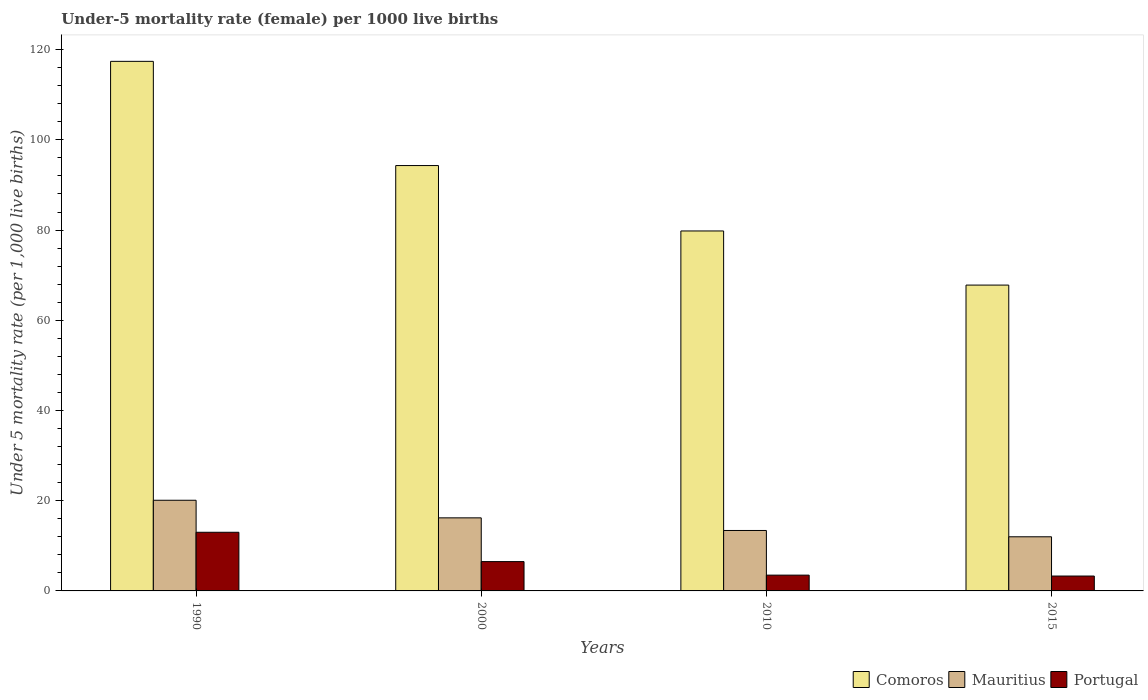How many different coloured bars are there?
Provide a short and direct response. 3. How many groups of bars are there?
Keep it short and to the point. 4. Are the number of bars per tick equal to the number of legend labels?
Ensure brevity in your answer.  Yes. Are the number of bars on each tick of the X-axis equal?
Your answer should be compact. Yes. How many bars are there on the 4th tick from the left?
Your answer should be compact. 3. How many bars are there on the 1st tick from the right?
Your answer should be very brief. 3. In how many cases, is the number of bars for a given year not equal to the number of legend labels?
Give a very brief answer. 0. What is the under-five mortality rate in Comoros in 2000?
Your answer should be very brief. 94.3. Across all years, what is the maximum under-five mortality rate in Comoros?
Keep it short and to the point. 117.4. In which year was the under-five mortality rate in Portugal maximum?
Your answer should be very brief. 1990. In which year was the under-five mortality rate in Comoros minimum?
Keep it short and to the point. 2015. What is the total under-five mortality rate in Portugal in the graph?
Your answer should be very brief. 26.3. What is the difference between the under-five mortality rate in Portugal in 2010 and that in 2015?
Your answer should be very brief. 0.2. What is the difference between the under-five mortality rate in Portugal in 2000 and the under-five mortality rate in Mauritius in 2010?
Your response must be concise. -6.9. What is the average under-five mortality rate in Mauritius per year?
Ensure brevity in your answer.  15.42. In the year 2010, what is the difference between the under-five mortality rate in Comoros and under-five mortality rate in Portugal?
Your answer should be very brief. 76.3. In how many years, is the under-five mortality rate in Portugal greater than 52?
Provide a succinct answer. 0. Is the under-five mortality rate in Portugal in 1990 less than that in 2000?
Ensure brevity in your answer.  No. What is the difference between the highest and the second highest under-five mortality rate in Portugal?
Give a very brief answer. 6.5. What is the difference between the highest and the lowest under-five mortality rate in Comoros?
Ensure brevity in your answer.  49.6. What does the 1st bar from the left in 1990 represents?
Give a very brief answer. Comoros. Is it the case that in every year, the sum of the under-five mortality rate in Comoros and under-five mortality rate in Portugal is greater than the under-five mortality rate in Mauritius?
Your response must be concise. Yes. How many years are there in the graph?
Give a very brief answer. 4. What is the difference between two consecutive major ticks on the Y-axis?
Give a very brief answer. 20. Are the values on the major ticks of Y-axis written in scientific E-notation?
Provide a succinct answer. No. Where does the legend appear in the graph?
Provide a short and direct response. Bottom right. What is the title of the graph?
Give a very brief answer. Under-5 mortality rate (female) per 1000 live births. Does "Lesotho" appear as one of the legend labels in the graph?
Ensure brevity in your answer.  No. What is the label or title of the Y-axis?
Keep it short and to the point. Under 5 mortality rate (per 1,0 live births). What is the Under 5 mortality rate (per 1,000 live births) in Comoros in 1990?
Ensure brevity in your answer.  117.4. What is the Under 5 mortality rate (per 1,000 live births) in Mauritius in 1990?
Your answer should be compact. 20.1. What is the Under 5 mortality rate (per 1,000 live births) in Portugal in 1990?
Your response must be concise. 13. What is the Under 5 mortality rate (per 1,000 live births) of Comoros in 2000?
Make the answer very short. 94.3. What is the Under 5 mortality rate (per 1,000 live births) in Mauritius in 2000?
Your answer should be compact. 16.2. What is the Under 5 mortality rate (per 1,000 live births) of Portugal in 2000?
Make the answer very short. 6.5. What is the Under 5 mortality rate (per 1,000 live births) in Comoros in 2010?
Offer a very short reply. 79.8. What is the Under 5 mortality rate (per 1,000 live births) of Mauritius in 2010?
Keep it short and to the point. 13.4. What is the Under 5 mortality rate (per 1,000 live births) of Portugal in 2010?
Ensure brevity in your answer.  3.5. What is the Under 5 mortality rate (per 1,000 live births) in Comoros in 2015?
Offer a terse response. 67.8. Across all years, what is the maximum Under 5 mortality rate (per 1,000 live births) of Comoros?
Your answer should be very brief. 117.4. Across all years, what is the maximum Under 5 mortality rate (per 1,000 live births) of Mauritius?
Provide a succinct answer. 20.1. Across all years, what is the minimum Under 5 mortality rate (per 1,000 live births) in Comoros?
Your answer should be very brief. 67.8. Across all years, what is the minimum Under 5 mortality rate (per 1,000 live births) of Portugal?
Your answer should be compact. 3.3. What is the total Under 5 mortality rate (per 1,000 live births) of Comoros in the graph?
Give a very brief answer. 359.3. What is the total Under 5 mortality rate (per 1,000 live births) in Mauritius in the graph?
Offer a terse response. 61.7. What is the total Under 5 mortality rate (per 1,000 live births) in Portugal in the graph?
Provide a succinct answer. 26.3. What is the difference between the Under 5 mortality rate (per 1,000 live births) of Comoros in 1990 and that in 2000?
Your answer should be compact. 23.1. What is the difference between the Under 5 mortality rate (per 1,000 live births) of Portugal in 1990 and that in 2000?
Give a very brief answer. 6.5. What is the difference between the Under 5 mortality rate (per 1,000 live births) in Comoros in 1990 and that in 2010?
Provide a short and direct response. 37.6. What is the difference between the Under 5 mortality rate (per 1,000 live births) of Mauritius in 1990 and that in 2010?
Your answer should be very brief. 6.7. What is the difference between the Under 5 mortality rate (per 1,000 live births) of Portugal in 1990 and that in 2010?
Your answer should be compact. 9.5. What is the difference between the Under 5 mortality rate (per 1,000 live births) in Comoros in 1990 and that in 2015?
Your response must be concise. 49.6. What is the difference between the Under 5 mortality rate (per 1,000 live births) of Mauritius in 1990 and that in 2015?
Ensure brevity in your answer.  8.1. What is the difference between the Under 5 mortality rate (per 1,000 live births) of Mauritius in 2000 and that in 2010?
Give a very brief answer. 2.8. What is the difference between the Under 5 mortality rate (per 1,000 live births) in Portugal in 2000 and that in 2010?
Keep it short and to the point. 3. What is the difference between the Under 5 mortality rate (per 1,000 live births) in Comoros in 2000 and that in 2015?
Offer a very short reply. 26.5. What is the difference between the Under 5 mortality rate (per 1,000 live births) in Mauritius in 2000 and that in 2015?
Provide a succinct answer. 4.2. What is the difference between the Under 5 mortality rate (per 1,000 live births) of Portugal in 2010 and that in 2015?
Your answer should be very brief. 0.2. What is the difference between the Under 5 mortality rate (per 1,000 live births) of Comoros in 1990 and the Under 5 mortality rate (per 1,000 live births) of Mauritius in 2000?
Offer a terse response. 101.2. What is the difference between the Under 5 mortality rate (per 1,000 live births) of Comoros in 1990 and the Under 5 mortality rate (per 1,000 live births) of Portugal in 2000?
Give a very brief answer. 110.9. What is the difference between the Under 5 mortality rate (per 1,000 live births) of Comoros in 1990 and the Under 5 mortality rate (per 1,000 live births) of Mauritius in 2010?
Your answer should be compact. 104. What is the difference between the Under 5 mortality rate (per 1,000 live births) of Comoros in 1990 and the Under 5 mortality rate (per 1,000 live births) of Portugal in 2010?
Your answer should be very brief. 113.9. What is the difference between the Under 5 mortality rate (per 1,000 live births) of Mauritius in 1990 and the Under 5 mortality rate (per 1,000 live births) of Portugal in 2010?
Make the answer very short. 16.6. What is the difference between the Under 5 mortality rate (per 1,000 live births) in Comoros in 1990 and the Under 5 mortality rate (per 1,000 live births) in Mauritius in 2015?
Provide a succinct answer. 105.4. What is the difference between the Under 5 mortality rate (per 1,000 live births) in Comoros in 1990 and the Under 5 mortality rate (per 1,000 live births) in Portugal in 2015?
Your answer should be compact. 114.1. What is the difference between the Under 5 mortality rate (per 1,000 live births) of Comoros in 2000 and the Under 5 mortality rate (per 1,000 live births) of Mauritius in 2010?
Keep it short and to the point. 80.9. What is the difference between the Under 5 mortality rate (per 1,000 live births) in Comoros in 2000 and the Under 5 mortality rate (per 1,000 live births) in Portugal in 2010?
Your response must be concise. 90.8. What is the difference between the Under 5 mortality rate (per 1,000 live births) in Comoros in 2000 and the Under 5 mortality rate (per 1,000 live births) in Mauritius in 2015?
Your answer should be compact. 82.3. What is the difference between the Under 5 mortality rate (per 1,000 live births) of Comoros in 2000 and the Under 5 mortality rate (per 1,000 live births) of Portugal in 2015?
Your answer should be very brief. 91. What is the difference between the Under 5 mortality rate (per 1,000 live births) in Mauritius in 2000 and the Under 5 mortality rate (per 1,000 live births) in Portugal in 2015?
Ensure brevity in your answer.  12.9. What is the difference between the Under 5 mortality rate (per 1,000 live births) of Comoros in 2010 and the Under 5 mortality rate (per 1,000 live births) of Mauritius in 2015?
Ensure brevity in your answer.  67.8. What is the difference between the Under 5 mortality rate (per 1,000 live births) in Comoros in 2010 and the Under 5 mortality rate (per 1,000 live births) in Portugal in 2015?
Provide a succinct answer. 76.5. What is the average Under 5 mortality rate (per 1,000 live births) in Comoros per year?
Give a very brief answer. 89.83. What is the average Under 5 mortality rate (per 1,000 live births) of Mauritius per year?
Your answer should be very brief. 15.43. What is the average Under 5 mortality rate (per 1,000 live births) in Portugal per year?
Your response must be concise. 6.58. In the year 1990, what is the difference between the Under 5 mortality rate (per 1,000 live births) in Comoros and Under 5 mortality rate (per 1,000 live births) in Mauritius?
Provide a short and direct response. 97.3. In the year 1990, what is the difference between the Under 5 mortality rate (per 1,000 live births) in Comoros and Under 5 mortality rate (per 1,000 live births) in Portugal?
Your answer should be compact. 104.4. In the year 2000, what is the difference between the Under 5 mortality rate (per 1,000 live births) in Comoros and Under 5 mortality rate (per 1,000 live births) in Mauritius?
Make the answer very short. 78.1. In the year 2000, what is the difference between the Under 5 mortality rate (per 1,000 live births) in Comoros and Under 5 mortality rate (per 1,000 live births) in Portugal?
Offer a terse response. 87.8. In the year 2010, what is the difference between the Under 5 mortality rate (per 1,000 live births) in Comoros and Under 5 mortality rate (per 1,000 live births) in Mauritius?
Ensure brevity in your answer.  66.4. In the year 2010, what is the difference between the Under 5 mortality rate (per 1,000 live births) in Comoros and Under 5 mortality rate (per 1,000 live births) in Portugal?
Make the answer very short. 76.3. In the year 2015, what is the difference between the Under 5 mortality rate (per 1,000 live births) in Comoros and Under 5 mortality rate (per 1,000 live births) in Mauritius?
Provide a short and direct response. 55.8. In the year 2015, what is the difference between the Under 5 mortality rate (per 1,000 live births) of Comoros and Under 5 mortality rate (per 1,000 live births) of Portugal?
Give a very brief answer. 64.5. What is the ratio of the Under 5 mortality rate (per 1,000 live births) of Comoros in 1990 to that in 2000?
Keep it short and to the point. 1.25. What is the ratio of the Under 5 mortality rate (per 1,000 live births) of Mauritius in 1990 to that in 2000?
Your answer should be compact. 1.24. What is the ratio of the Under 5 mortality rate (per 1,000 live births) in Comoros in 1990 to that in 2010?
Your answer should be very brief. 1.47. What is the ratio of the Under 5 mortality rate (per 1,000 live births) in Portugal in 1990 to that in 2010?
Offer a very short reply. 3.71. What is the ratio of the Under 5 mortality rate (per 1,000 live births) in Comoros in 1990 to that in 2015?
Offer a very short reply. 1.73. What is the ratio of the Under 5 mortality rate (per 1,000 live births) of Mauritius in 1990 to that in 2015?
Offer a very short reply. 1.68. What is the ratio of the Under 5 mortality rate (per 1,000 live births) in Portugal in 1990 to that in 2015?
Give a very brief answer. 3.94. What is the ratio of the Under 5 mortality rate (per 1,000 live births) of Comoros in 2000 to that in 2010?
Your response must be concise. 1.18. What is the ratio of the Under 5 mortality rate (per 1,000 live births) in Mauritius in 2000 to that in 2010?
Give a very brief answer. 1.21. What is the ratio of the Under 5 mortality rate (per 1,000 live births) in Portugal in 2000 to that in 2010?
Keep it short and to the point. 1.86. What is the ratio of the Under 5 mortality rate (per 1,000 live births) of Comoros in 2000 to that in 2015?
Your answer should be compact. 1.39. What is the ratio of the Under 5 mortality rate (per 1,000 live births) in Mauritius in 2000 to that in 2015?
Your answer should be compact. 1.35. What is the ratio of the Under 5 mortality rate (per 1,000 live births) in Portugal in 2000 to that in 2015?
Make the answer very short. 1.97. What is the ratio of the Under 5 mortality rate (per 1,000 live births) of Comoros in 2010 to that in 2015?
Your answer should be compact. 1.18. What is the ratio of the Under 5 mortality rate (per 1,000 live births) in Mauritius in 2010 to that in 2015?
Make the answer very short. 1.12. What is the ratio of the Under 5 mortality rate (per 1,000 live births) in Portugal in 2010 to that in 2015?
Your answer should be compact. 1.06. What is the difference between the highest and the second highest Under 5 mortality rate (per 1,000 live births) of Comoros?
Your response must be concise. 23.1. What is the difference between the highest and the second highest Under 5 mortality rate (per 1,000 live births) of Portugal?
Offer a very short reply. 6.5. What is the difference between the highest and the lowest Under 5 mortality rate (per 1,000 live births) of Comoros?
Your answer should be compact. 49.6. What is the difference between the highest and the lowest Under 5 mortality rate (per 1,000 live births) in Mauritius?
Ensure brevity in your answer.  8.1. What is the difference between the highest and the lowest Under 5 mortality rate (per 1,000 live births) in Portugal?
Provide a succinct answer. 9.7. 